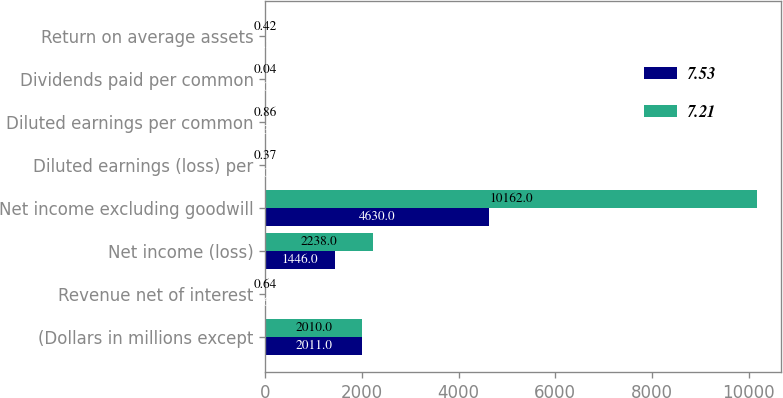Convert chart. <chart><loc_0><loc_0><loc_500><loc_500><stacked_bar_chart><ecel><fcel>(Dollars in millions except<fcel>Revenue net of interest<fcel>Net income (loss)<fcel>Net income excluding goodwill<fcel>Diluted earnings (loss) per<fcel>Diluted earnings per common<fcel>Dividends paid per common<fcel>Return on average assets<nl><fcel>7.53<fcel>2011<fcel>0.64<fcel>1446<fcel>4630<fcel>0.01<fcel>0.32<fcel>0.04<fcel>0.2<nl><fcel>7.21<fcel>2010<fcel>0.64<fcel>2238<fcel>10162<fcel>0.37<fcel>0.86<fcel>0.04<fcel>0.42<nl></chart> 